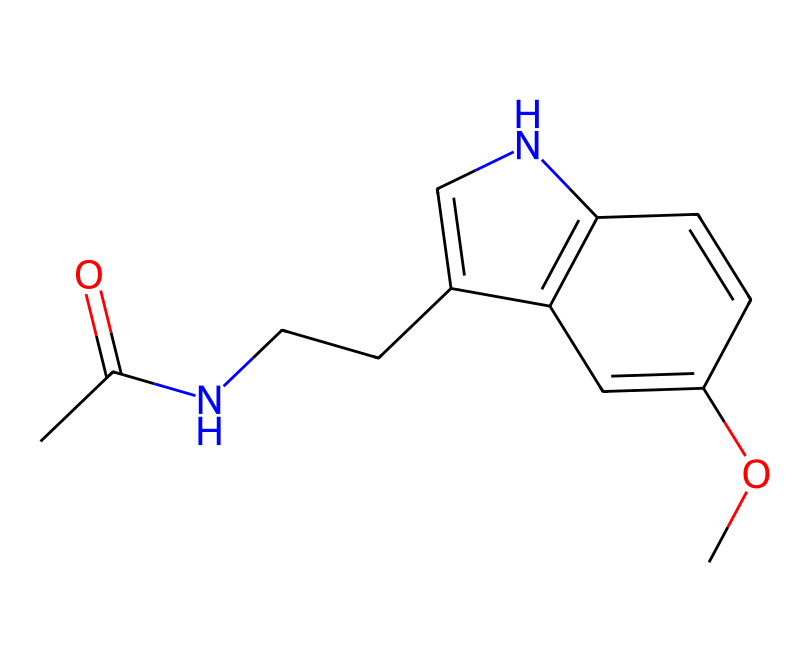What is the main functional group present in this chemical? The structure contains an amide group (CC(=O)N), which is characterized by a carbonyl group (C=O) attached to a nitrogen atom. This is the defining functional group in the molecule.
Answer: amide How many rings are present in the structure? By examining the SMILES, there are two rings evident in the structure: one pyrrole ring and one aromatic ring. This can be identified based on the cyclic components in the representation.
Answer: 2 What is the relationship between melatonin and sleep regulation? Melatonin is a hormone primarily responsible for regulating sleep-wake cycles; it is produced in response to dark conditions and inhibited by light exposure, particularly blue light. This physiological role is directly linked to how its structure supports its function.
Answer: regulates sleep How many carbon (C) atoms are in the chemical structure? The hydrogen atoms are implicit in the SMILES notation, and by counting explicitly noted carbon atoms, there are 12 total carbon atoms present in the structure of melatonin.
Answer: 12 What type of bond connects the nitrogen atom in the amide group to the carbon chain? The nitrogens in the amide group form a single bond with the carbon chain. This is identifiable through the notation where the nitrogen directly follows the carbon.
Answer: single bond What differentiates this compound as an antioxidant? The presence of specific functional groups, particularly the ability to donate electrons and neutralize free radicals, characterizes this molecule as an antioxidant, making it effective in combating oxidative stress in the body.
Answer: antioxidant function 